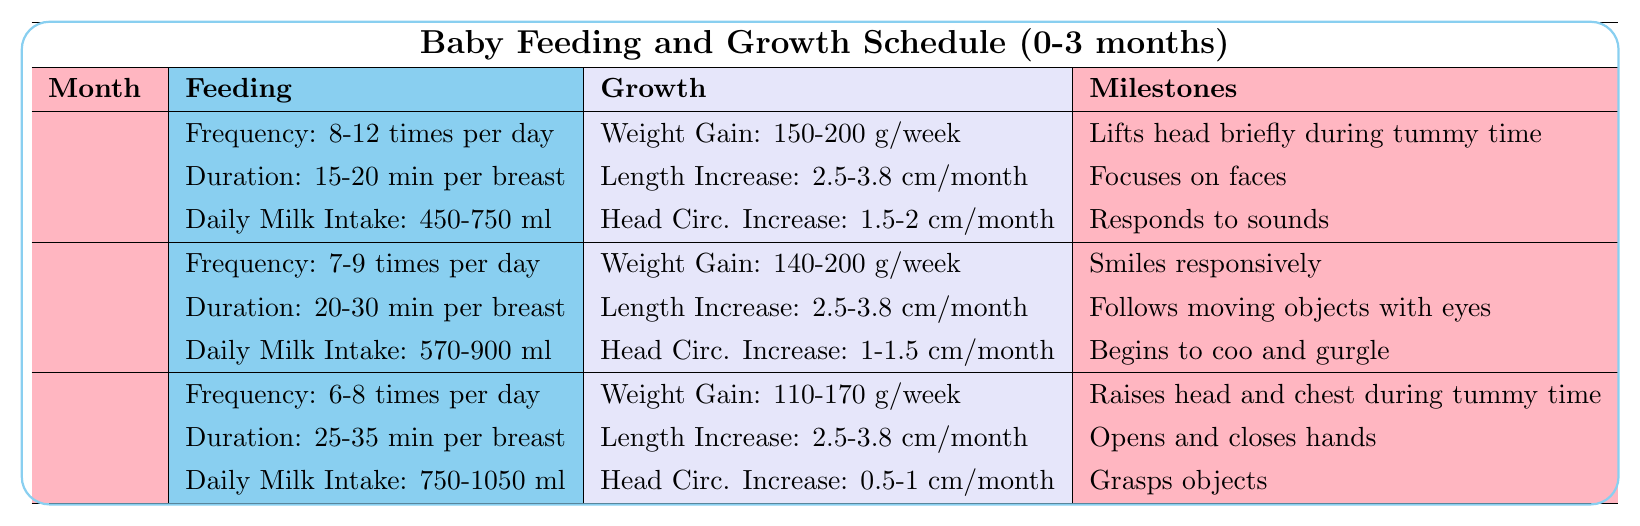What is the daily milk intake for Month 2? According to the table, the daily milk intake for Month 2 is stated as 570-900 ml.
Answer: 570-900 ml How many times per day should a baby be fed in Month 1? The table indicates that the feeding frequency for Month 1 is 8-12 times per day.
Answer: 8-12 times per day What is the weight gain range for a baby during Month 3? The table shows that the weight gain for Month 3 is between 110-170 grams per week.
Answer: 110-170 grams per week Is the head circumference increase in Month 2 greater than in Month 3? The increase in head circumference for Month 2 is 1-1.5 cm, whereas for Month 3 it is 0.5-1 cm, making the increase in Month 2 greater.
Answer: Yes What is the average frequency of feedings for the first three months? To calculate the average frequency: Month 1 (8-12), Month 2 (7-9), Month 3 (6-8). The range of averages is (8+12)/2, (7+9)/2, (6+8)/2 which gives us 10, 8, and 7, respectively. The average of these values is (10 + 8 + 7)/3 = 8.33, but we summarize it as 8-10 occurrences, considering the ranges.
Answer: 8-10 times per day What milestones are achieved in Month 3? The milestones listed for Month 3 are: "Raises head and chest during tummy time," "Opens and closes hands," and "Grasps objects."
Answer: Raises head and chest during tummy time, opens and closes hands, grasps objects How much weight gain does a baby experience from Month 1 to Month 2 at the highest end of the ranges? The highest weight gain for Month 1 is 200 grams per week and for Month 2 is 200 grams per week, making it unchanged over the two months.
Answer: 0 grams (unchanged) What feeding duration is suggested for Month 2 compared to Month 1? The feeding duration for Month 1 is 15-20 minutes per breast, and for Month 2, it's 20-30 minutes per breast. This suggests that the duration increases by 5-10 minutes per breast.
Answer: Increases by 5-10 minutes per breast Which month has the most significant range of daily milk intake? Month 3 shows the most significant range for daily milk intake as it goes from 750-1050 ml, compared to Month 1 (450-750 ml) and Month 2 (570-900 ml).
Answer: Month 3 What is the common breastfeeding challenge related to low milk supply? The solution for low milk supply as per the table is to increase nursing frequency, stay hydrated, and consider power pumping.
Answer: Increase nursing frequency, stay hydrated, consider power pumping Which milestone involves the baby's physical development during tummy time in Month 1? The milestone involving physical development is "Lifts head briefly during tummy time."
Answer: Lifts head briefly during tummy time 